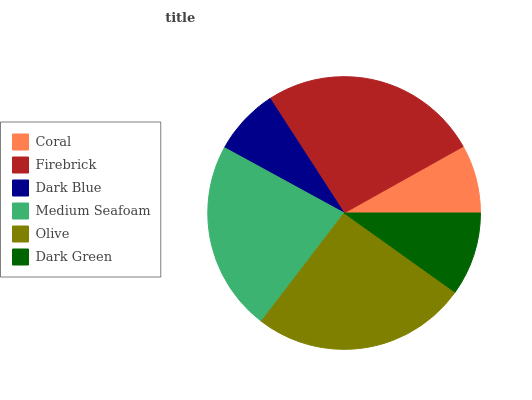Is Dark Blue the minimum?
Answer yes or no. Yes. Is Firebrick the maximum?
Answer yes or no. Yes. Is Firebrick the minimum?
Answer yes or no. No. Is Dark Blue the maximum?
Answer yes or no. No. Is Firebrick greater than Dark Blue?
Answer yes or no. Yes. Is Dark Blue less than Firebrick?
Answer yes or no. Yes. Is Dark Blue greater than Firebrick?
Answer yes or no. No. Is Firebrick less than Dark Blue?
Answer yes or no. No. Is Medium Seafoam the high median?
Answer yes or no. Yes. Is Dark Green the low median?
Answer yes or no. Yes. Is Olive the high median?
Answer yes or no. No. Is Dark Blue the low median?
Answer yes or no. No. 